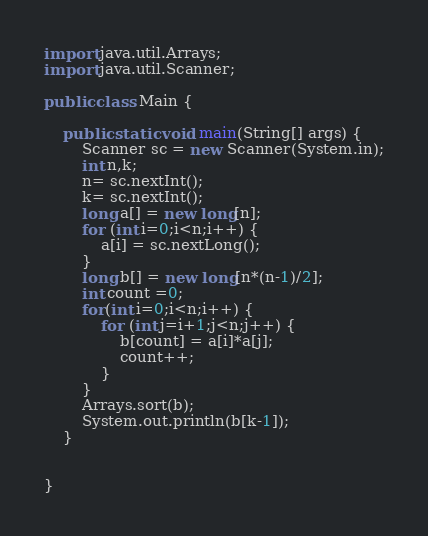Convert code to text. <code><loc_0><loc_0><loc_500><loc_500><_Java_>import java.util.Arrays;
import java.util.Scanner;

public class Main {

	public static void main(String[] args) {
		Scanner sc = new Scanner(System.in);
		int n,k;
		n= sc.nextInt();
		k= sc.nextInt();
		long a[] = new long[n];
		for (int i=0;i<n;i++) {
			a[i] = sc.nextLong();
		}
		long b[] = new long[n*(n-1)/2];
		int count =0;
		for(int i=0;i<n;i++) {
			for (int j=i+1;j<n;j++) {
				b[count] = a[i]*a[j];
				count++;
			}
		}
		Arrays.sort(b);
		System.out.println(b[k-1]);
	}


}</code> 